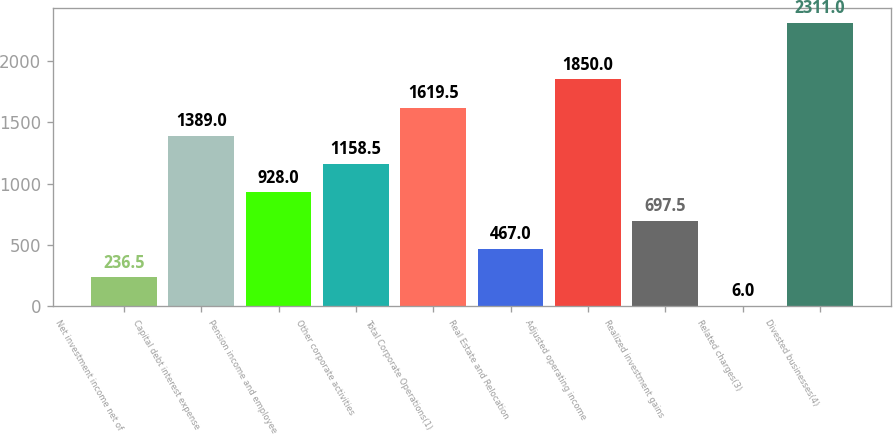<chart> <loc_0><loc_0><loc_500><loc_500><bar_chart><fcel>Net investment income net of<fcel>Capital debt interest expense<fcel>Pension income and employee<fcel>Other corporate activities<fcel>Total Corporate Operations(1)<fcel>Real Estate and Relocation<fcel>Adjusted operating income<fcel>Realized investment gains<fcel>Related charges(3)<fcel>Divested businesses(4)<nl><fcel>236.5<fcel>1389<fcel>928<fcel>1158.5<fcel>1619.5<fcel>467<fcel>1850<fcel>697.5<fcel>6<fcel>2311<nl></chart> 